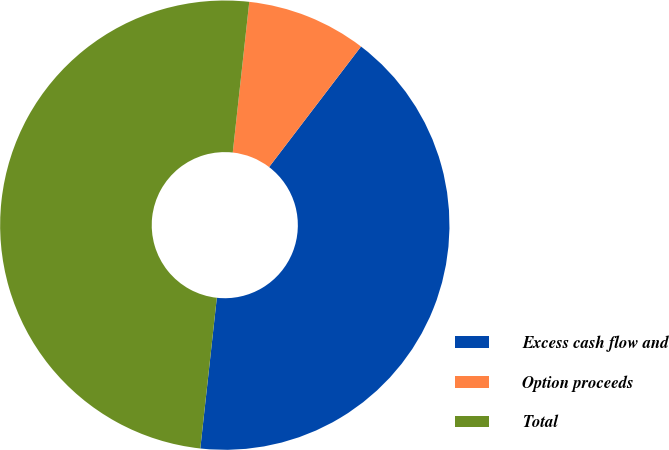Convert chart. <chart><loc_0><loc_0><loc_500><loc_500><pie_chart><fcel>Excess cash flow and<fcel>Option proceeds<fcel>Total<nl><fcel>41.37%<fcel>8.63%<fcel>50.0%<nl></chart> 